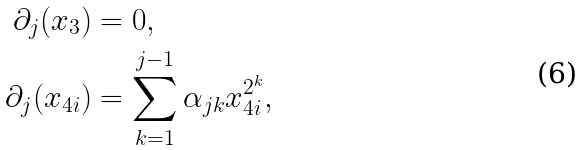<formula> <loc_0><loc_0><loc_500><loc_500>\partial _ { j } ( x _ { 3 } ) & = 0 , \\ \partial _ { j } ( x _ { 4 i } ) & = \sum _ { k = 1 } ^ { j - 1 } \alpha _ { j k } x _ { 4 i } ^ { 2 ^ { k } } ,</formula> 